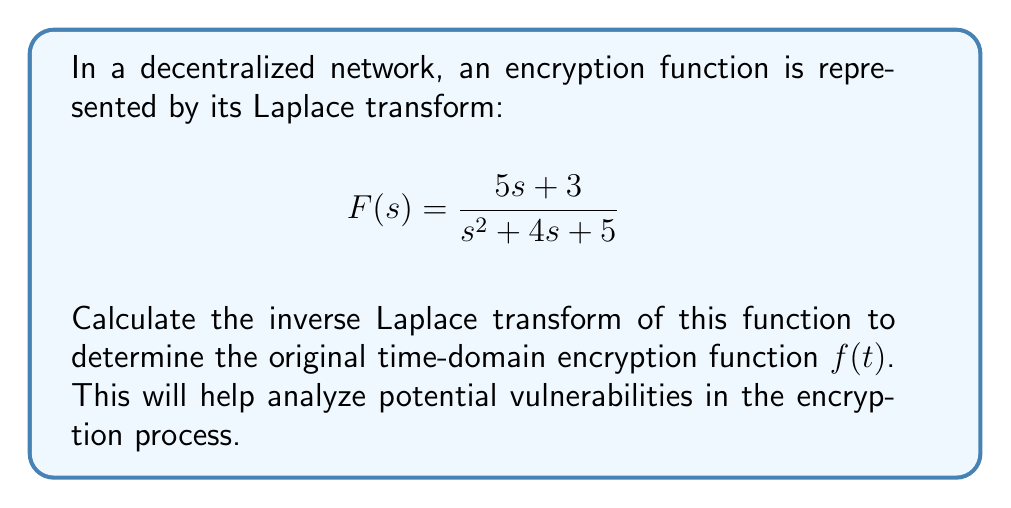Can you solve this math problem? To find the inverse Laplace transform, we'll follow these steps:

1) First, we need to factor the denominator of $F(s)$:
   $$s^2 + 4s + 5 = (s+2)^2 + 1 = (s+2+i)(s+2-i)$$

2) Now, we can express $F(s)$ in partial fraction decomposition:
   $$F(s) = \frac{5s + 3}{(s+2+i)(s+2-i)} = \frac{A}{s+2+i} + \frac{B}{s+2-i}$$

3) To find $A$ and $B$, multiply both sides by $(s+2+i)(s+2-i)$:
   $$5s + 3 = A(s+2-i) + B(s+2+i)$$

4) Substitute $s = -2+i$ and $s = -2-i$ to find $A$ and $B$:
   For $s = -2+i$: $5(-2+i) + 3 = 2Ai$, so $A = \frac{-7+5i}{2i} = \frac{5+7i}{2}$
   For $s = -2-i$: $5(-2-i) + 3 = -2Bi$, so $B = \frac{-7-5i}{-2i} = \frac{5-7i}{2}$

5) Now we have:
   $$F(s) = \frac{\frac{5+7i}{2}}{s+2+i} + \frac{\frac{5-7i}{2}}{s+2-i}$$

6) The inverse Laplace transform of $\frac{1}{s+a+bi}$ is $e^{-(a+bi)t}$. Therefore:
   $$f(t) = \frac{5+7i}{2}e^{-(2+i)t} + \frac{5-7i}{2}e^{-(2-i)t}$$

7) Simplify using Euler's formula:
   $$f(t) = e^{-2t}[(5\cos t + 7\sin t) + i(7\cos t - 5\sin t)]$$

8) Since $f(t)$ must be real, we take the real part:
   $$f(t) = e^{-2t}(5\cos t + 7\sin t)$$
Answer: $f(t) = e^{-2t}(5\cos t + 7\sin t)$ 